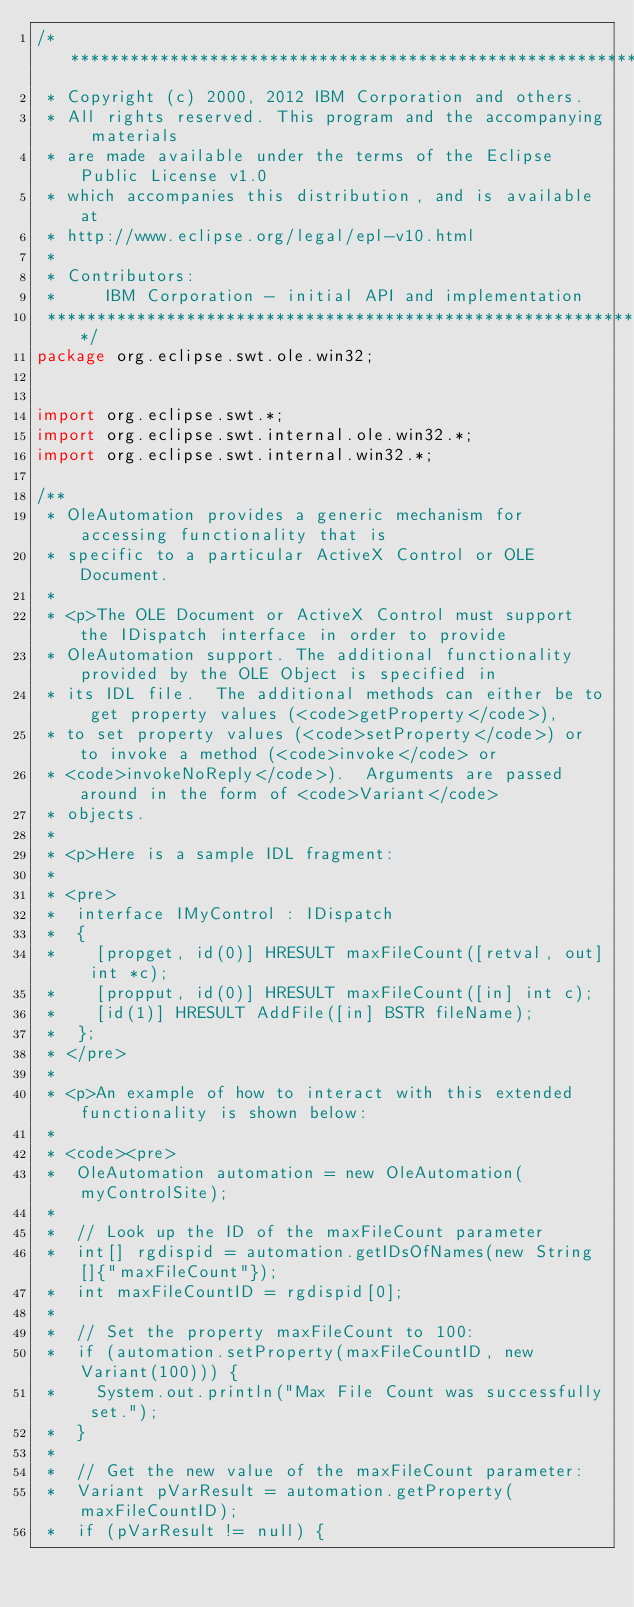Convert code to text. <code><loc_0><loc_0><loc_500><loc_500><_Java_>/*******************************************************************************
 * Copyright (c) 2000, 2012 IBM Corporation and others.
 * All rights reserved. This program and the accompanying materials
 * are made available under the terms of the Eclipse Public License v1.0
 * which accompanies this distribution, and is available at
 * http://www.eclipse.org/legal/epl-v10.html
 *
 * Contributors:
 *     IBM Corporation - initial API and implementation
 *******************************************************************************/
package org.eclipse.swt.ole.win32;


import org.eclipse.swt.*;
import org.eclipse.swt.internal.ole.win32.*;
import org.eclipse.swt.internal.win32.*;

/**
 * OleAutomation provides a generic mechanism for accessing functionality that is 
 * specific to a particular ActiveX Control or OLE Document.
 *
 * <p>The OLE Document or ActiveX Control must support the IDispatch interface in order to provide
 * OleAutomation support. The additional functionality provided by the OLE Object is specified in 
 * its IDL file.  The additional methods can either be to get property values (<code>getProperty</code>), 
 * to set property values (<code>setProperty</code>) or to invoke a method (<code>invoke</code> or
 * <code>invokeNoReply</code>).  Arguments are passed around in the form of <code>Variant</code> 
 * objects.
 *
 * <p>Here is a sample IDL fragment:
 *
 * <pre>
 *	interface IMyControl : IDispatch
 *	{
 *		[propget, id(0)] HRESULT maxFileCount([retval, out] int *c);
 *		[propput, id(0)] HRESULT maxFileCount([in] int c);
 *		[id(1)]	HRESULT AddFile([in] BSTR fileName);
 *	};
 * </pre>
 *
 * <p>An example of how to interact with this extended functionality is shown below:
 *
 * <code><pre>
 *	OleAutomation automation = new OleAutomation(myControlSite);
 *
 *	// Look up the ID of the maxFileCount parameter
 *	int[] rgdispid = automation.getIDsOfNames(new String[]{"maxFileCount"});
 *	int maxFileCountID = rgdispid[0];
 *
 *	// Set the property maxFileCount to 100:
 *	if (automation.setProperty(maxFileCountID, new Variant(100))) {
 *		System.out.println("Max File Count was successfully set.");
 *	}
 *
 *	// Get the new value of the maxFileCount parameter:
 *	Variant pVarResult = automation.getProperty(maxFileCountID);
 *	if (pVarResult != null) {</code> 